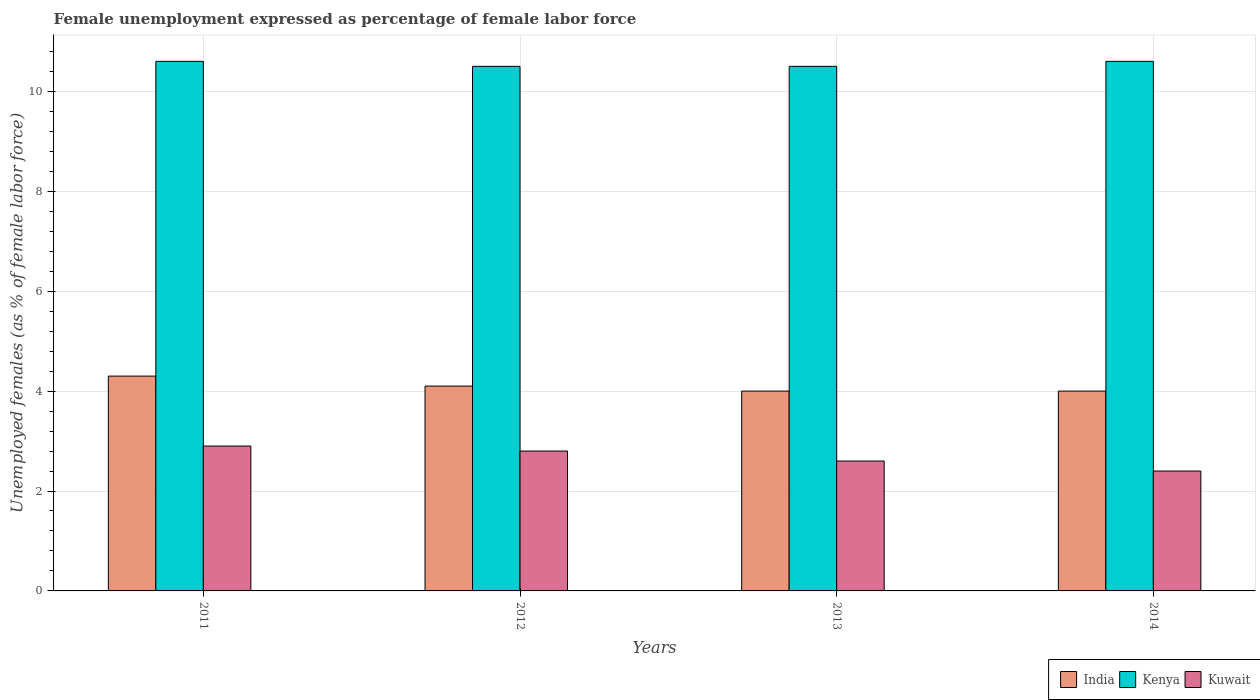How many different coloured bars are there?
Your answer should be compact. 3. How many groups of bars are there?
Give a very brief answer. 4. Are the number of bars per tick equal to the number of legend labels?
Provide a succinct answer. Yes. In how many cases, is the number of bars for a given year not equal to the number of legend labels?
Offer a very short reply. 0. What is the unemployment in females in in Kuwait in 2012?
Give a very brief answer. 2.8. Across all years, what is the maximum unemployment in females in in Kuwait?
Give a very brief answer. 2.9. Across all years, what is the minimum unemployment in females in in India?
Offer a terse response. 4. In which year was the unemployment in females in in India minimum?
Offer a terse response. 2013. What is the total unemployment in females in in Kuwait in the graph?
Your answer should be very brief. 10.7. What is the difference between the unemployment in females in in India in 2011 and that in 2012?
Provide a short and direct response. 0.2. What is the difference between the unemployment in females in in Kuwait in 2012 and the unemployment in females in in Kenya in 2013?
Make the answer very short. -7.7. What is the average unemployment in females in in Kuwait per year?
Provide a short and direct response. 2.68. In the year 2012, what is the difference between the unemployment in females in in India and unemployment in females in in Kuwait?
Your answer should be compact. 1.3. What is the ratio of the unemployment in females in in Kuwait in 2011 to that in 2012?
Make the answer very short. 1.04. Is the unemployment in females in in Kuwait in 2011 less than that in 2012?
Keep it short and to the point. No. Is the difference between the unemployment in females in in India in 2011 and 2013 greater than the difference between the unemployment in females in in Kuwait in 2011 and 2013?
Provide a succinct answer. No. What is the difference between the highest and the second highest unemployment in females in in Kuwait?
Provide a succinct answer. 0.1. What is the difference between the highest and the lowest unemployment in females in in India?
Provide a succinct answer. 0.3. What does the 3rd bar from the left in 2012 represents?
Provide a succinct answer. Kuwait. What does the 3rd bar from the right in 2012 represents?
Provide a short and direct response. India. Is it the case that in every year, the sum of the unemployment in females in in Kenya and unemployment in females in in Kuwait is greater than the unemployment in females in in India?
Your answer should be very brief. Yes. Are all the bars in the graph horizontal?
Make the answer very short. No. How many years are there in the graph?
Provide a succinct answer. 4. Does the graph contain grids?
Provide a succinct answer. Yes. What is the title of the graph?
Offer a very short reply. Female unemployment expressed as percentage of female labor force. What is the label or title of the Y-axis?
Offer a very short reply. Unemployed females (as % of female labor force). What is the Unemployed females (as % of female labor force) of India in 2011?
Keep it short and to the point. 4.3. What is the Unemployed females (as % of female labor force) in Kenya in 2011?
Make the answer very short. 10.6. What is the Unemployed females (as % of female labor force) of Kuwait in 2011?
Offer a terse response. 2.9. What is the Unemployed females (as % of female labor force) of India in 2012?
Provide a short and direct response. 4.1. What is the Unemployed females (as % of female labor force) in Kuwait in 2012?
Provide a succinct answer. 2.8. What is the Unemployed females (as % of female labor force) in India in 2013?
Your answer should be compact. 4. What is the Unemployed females (as % of female labor force) in Kenya in 2013?
Your answer should be very brief. 10.5. What is the Unemployed females (as % of female labor force) of Kuwait in 2013?
Ensure brevity in your answer.  2.6. What is the Unemployed females (as % of female labor force) of India in 2014?
Offer a terse response. 4. What is the Unemployed females (as % of female labor force) in Kenya in 2014?
Make the answer very short. 10.6. What is the Unemployed females (as % of female labor force) of Kuwait in 2014?
Ensure brevity in your answer.  2.4. Across all years, what is the maximum Unemployed females (as % of female labor force) in India?
Offer a terse response. 4.3. Across all years, what is the maximum Unemployed females (as % of female labor force) of Kenya?
Your answer should be very brief. 10.6. Across all years, what is the maximum Unemployed females (as % of female labor force) of Kuwait?
Offer a very short reply. 2.9. Across all years, what is the minimum Unemployed females (as % of female labor force) in Kenya?
Offer a terse response. 10.5. Across all years, what is the minimum Unemployed females (as % of female labor force) of Kuwait?
Your answer should be very brief. 2.4. What is the total Unemployed females (as % of female labor force) of India in the graph?
Your answer should be compact. 16.4. What is the total Unemployed females (as % of female labor force) of Kenya in the graph?
Offer a very short reply. 42.2. What is the total Unemployed females (as % of female labor force) in Kuwait in the graph?
Provide a succinct answer. 10.7. What is the difference between the Unemployed females (as % of female labor force) of India in 2011 and that in 2012?
Offer a very short reply. 0.2. What is the difference between the Unemployed females (as % of female labor force) of Kuwait in 2011 and that in 2012?
Keep it short and to the point. 0.1. What is the difference between the Unemployed females (as % of female labor force) of India in 2011 and that in 2013?
Your answer should be compact. 0.3. What is the difference between the Unemployed females (as % of female labor force) in Kenya in 2011 and that in 2014?
Ensure brevity in your answer.  0. What is the difference between the Unemployed females (as % of female labor force) of Kuwait in 2011 and that in 2014?
Provide a short and direct response. 0.5. What is the difference between the Unemployed females (as % of female labor force) in Kuwait in 2012 and that in 2013?
Keep it short and to the point. 0.2. What is the difference between the Unemployed females (as % of female labor force) in India in 2012 and that in 2014?
Your answer should be compact. 0.1. What is the difference between the Unemployed females (as % of female labor force) in Kenya in 2012 and that in 2014?
Provide a succinct answer. -0.1. What is the difference between the Unemployed females (as % of female labor force) of Kuwait in 2013 and that in 2014?
Offer a very short reply. 0.2. What is the difference between the Unemployed females (as % of female labor force) of India in 2011 and the Unemployed females (as % of female labor force) of Kenya in 2012?
Keep it short and to the point. -6.2. What is the difference between the Unemployed females (as % of female labor force) of Kenya in 2011 and the Unemployed females (as % of female labor force) of Kuwait in 2012?
Ensure brevity in your answer.  7.8. What is the difference between the Unemployed females (as % of female labor force) in India in 2011 and the Unemployed females (as % of female labor force) in Kenya in 2013?
Offer a very short reply. -6.2. What is the difference between the Unemployed females (as % of female labor force) in India in 2011 and the Unemployed females (as % of female labor force) in Kuwait in 2014?
Provide a succinct answer. 1.9. What is the difference between the Unemployed females (as % of female labor force) in Kenya in 2011 and the Unemployed females (as % of female labor force) in Kuwait in 2014?
Give a very brief answer. 8.2. What is the difference between the Unemployed females (as % of female labor force) of India in 2012 and the Unemployed females (as % of female labor force) of Kenya in 2013?
Your answer should be very brief. -6.4. What is the difference between the Unemployed females (as % of female labor force) in Kenya in 2012 and the Unemployed females (as % of female labor force) in Kuwait in 2014?
Give a very brief answer. 8.1. What is the difference between the Unemployed females (as % of female labor force) in India in 2013 and the Unemployed females (as % of female labor force) in Kuwait in 2014?
Give a very brief answer. 1.6. What is the average Unemployed females (as % of female labor force) in Kenya per year?
Provide a short and direct response. 10.55. What is the average Unemployed females (as % of female labor force) of Kuwait per year?
Keep it short and to the point. 2.67. In the year 2011, what is the difference between the Unemployed females (as % of female labor force) of India and Unemployed females (as % of female labor force) of Kenya?
Give a very brief answer. -6.3. In the year 2011, what is the difference between the Unemployed females (as % of female labor force) of India and Unemployed females (as % of female labor force) of Kuwait?
Your answer should be very brief. 1.4. In the year 2012, what is the difference between the Unemployed females (as % of female labor force) in India and Unemployed females (as % of female labor force) in Kenya?
Your response must be concise. -6.4. In the year 2012, what is the difference between the Unemployed females (as % of female labor force) in India and Unemployed females (as % of female labor force) in Kuwait?
Keep it short and to the point. 1.3. In the year 2013, what is the difference between the Unemployed females (as % of female labor force) of India and Unemployed females (as % of female labor force) of Kuwait?
Provide a short and direct response. 1.4. In the year 2014, what is the difference between the Unemployed females (as % of female labor force) in India and Unemployed females (as % of female labor force) in Kuwait?
Make the answer very short. 1.6. In the year 2014, what is the difference between the Unemployed females (as % of female labor force) in Kenya and Unemployed females (as % of female labor force) in Kuwait?
Provide a succinct answer. 8.2. What is the ratio of the Unemployed females (as % of female labor force) in India in 2011 to that in 2012?
Make the answer very short. 1.05. What is the ratio of the Unemployed females (as % of female labor force) of Kenya in 2011 to that in 2012?
Make the answer very short. 1.01. What is the ratio of the Unemployed females (as % of female labor force) of Kuwait in 2011 to that in 2012?
Keep it short and to the point. 1.04. What is the ratio of the Unemployed females (as % of female labor force) in India in 2011 to that in 2013?
Offer a terse response. 1.07. What is the ratio of the Unemployed females (as % of female labor force) of Kenya in 2011 to that in 2013?
Keep it short and to the point. 1.01. What is the ratio of the Unemployed females (as % of female labor force) in Kuwait in 2011 to that in 2013?
Offer a terse response. 1.12. What is the ratio of the Unemployed females (as % of female labor force) in India in 2011 to that in 2014?
Provide a succinct answer. 1.07. What is the ratio of the Unemployed females (as % of female labor force) of Kenya in 2011 to that in 2014?
Provide a short and direct response. 1. What is the ratio of the Unemployed females (as % of female labor force) of Kuwait in 2011 to that in 2014?
Offer a very short reply. 1.21. What is the ratio of the Unemployed females (as % of female labor force) of India in 2012 to that in 2013?
Offer a terse response. 1.02. What is the ratio of the Unemployed females (as % of female labor force) of Kenya in 2012 to that in 2014?
Ensure brevity in your answer.  0.99. What is the ratio of the Unemployed females (as % of female labor force) of Kuwait in 2012 to that in 2014?
Your answer should be very brief. 1.17. What is the ratio of the Unemployed females (as % of female labor force) in India in 2013 to that in 2014?
Ensure brevity in your answer.  1. What is the ratio of the Unemployed females (as % of female labor force) in Kenya in 2013 to that in 2014?
Ensure brevity in your answer.  0.99. What is the difference between the highest and the second highest Unemployed females (as % of female labor force) of Kenya?
Provide a succinct answer. 0. What is the difference between the highest and the second highest Unemployed females (as % of female labor force) of Kuwait?
Your answer should be very brief. 0.1. What is the difference between the highest and the lowest Unemployed females (as % of female labor force) of Kuwait?
Offer a terse response. 0.5. 